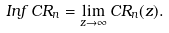Convert formula to latex. <formula><loc_0><loc_0><loc_500><loc_500>I n f \, C R _ { n } = \lim _ { z \to \infty } C R _ { n } ( z ) .</formula> 